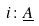<formula> <loc_0><loc_0><loc_500><loc_500>i \colon \underline { A }</formula> 